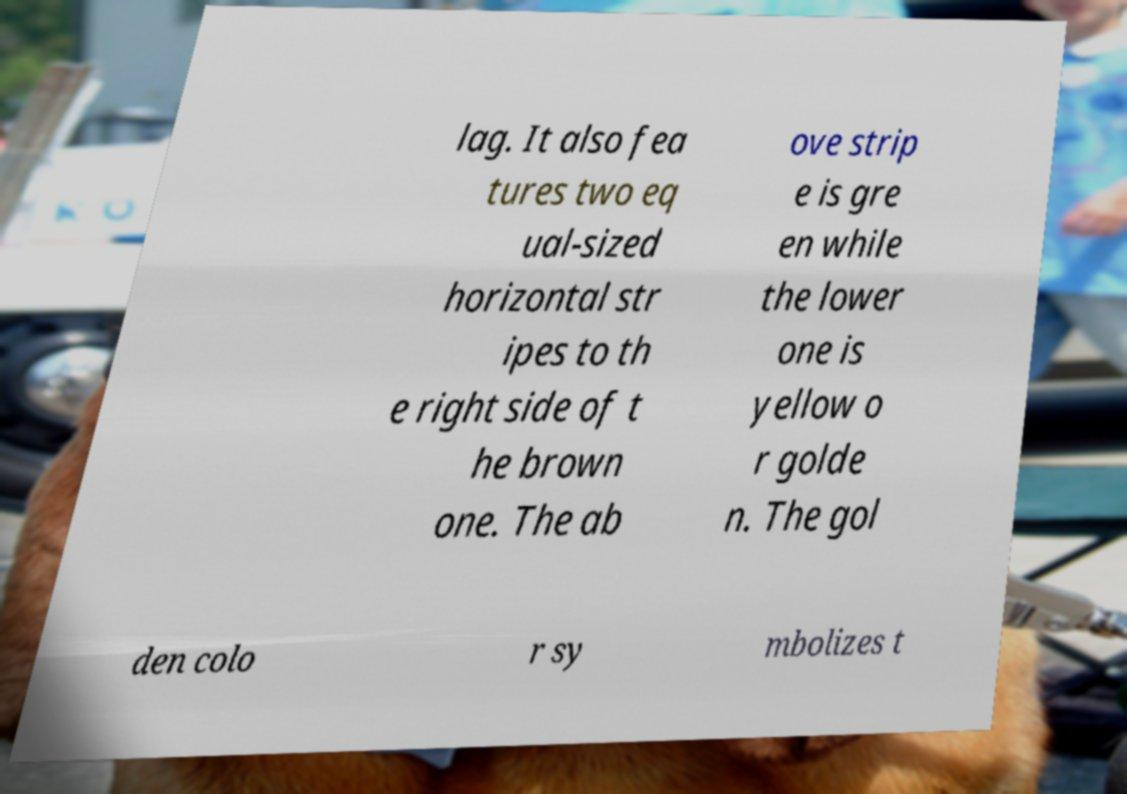Could you assist in decoding the text presented in this image and type it out clearly? lag. It also fea tures two eq ual-sized horizontal str ipes to th e right side of t he brown one. The ab ove strip e is gre en while the lower one is yellow o r golde n. The gol den colo r sy mbolizes t 